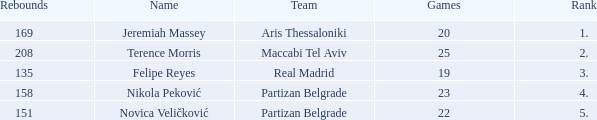What is the number of Games for the Maccabi Tel Aviv Team with less than 208 Rebounds? None. 